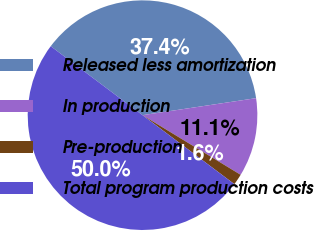<chart> <loc_0><loc_0><loc_500><loc_500><pie_chart><fcel>Released less amortization<fcel>In production<fcel>Pre-production<fcel>Total program production costs<nl><fcel>37.38%<fcel>11.06%<fcel>1.56%<fcel>50.0%<nl></chart> 